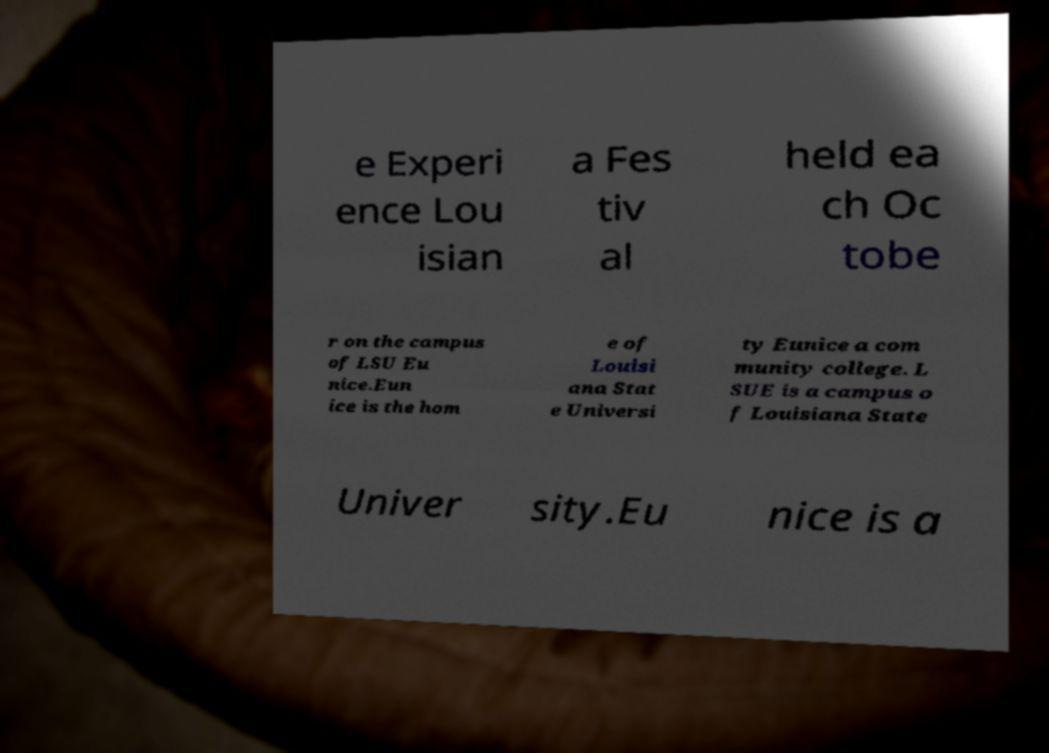Could you extract and type out the text from this image? e Experi ence Lou isian a Fes tiv al held ea ch Oc tobe r on the campus of LSU Eu nice.Eun ice is the hom e of Louisi ana Stat e Universi ty Eunice a com munity college. L SUE is a campus o f Louisiana State Univer sity.Eu nice is a 